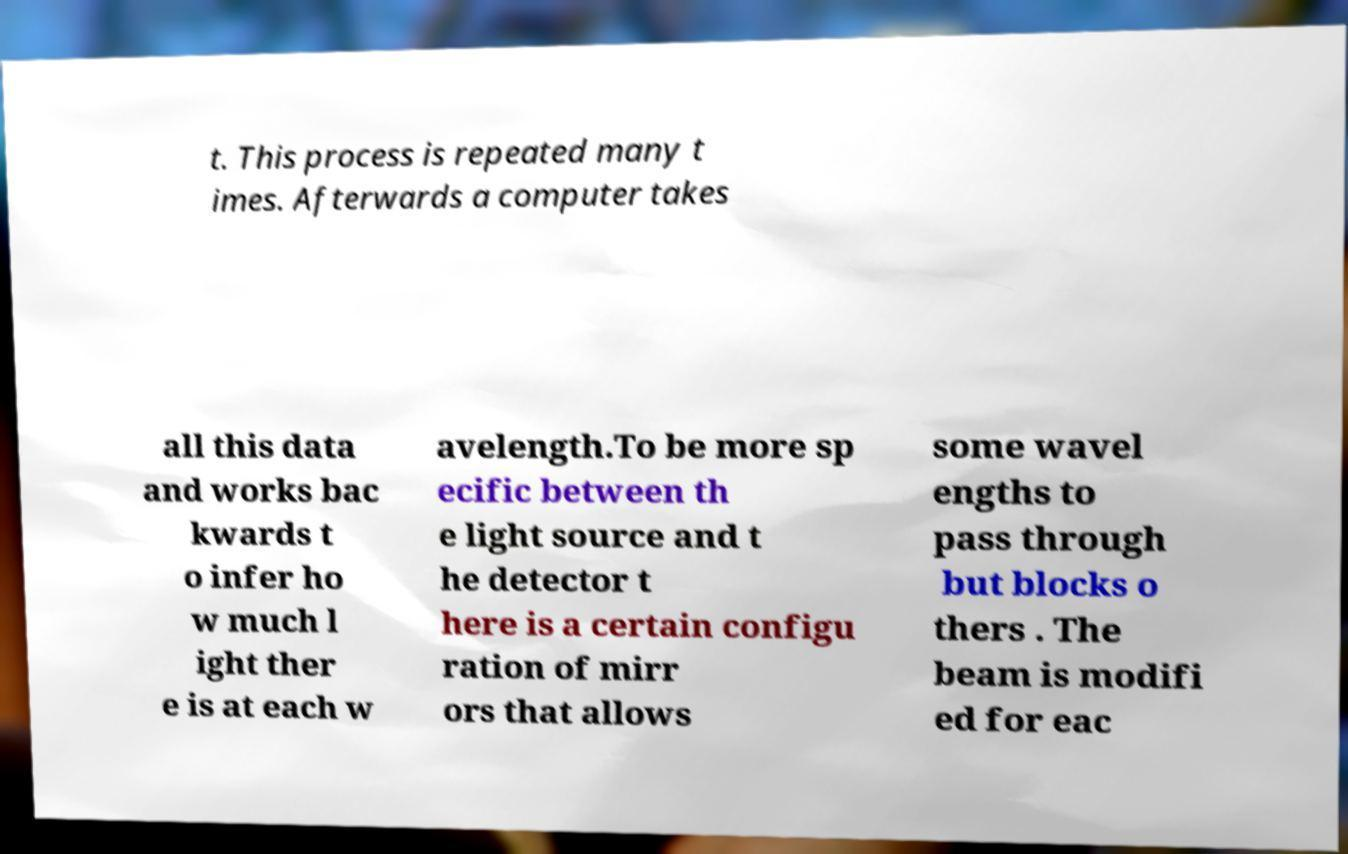What messages or text are displayed in this image? I need them in a readable, typed format. t. This process is repeated many t imes. Afterwards a computer takes all this data and works bac kwards t o infer ho w much l ight ther e is at each w avelength.To be more sp ecific between th e light source and t he detector t here is a certain configu ration of mirr ors that allows some wavel engths to pass through but blocks o thers . The beam is modifi ed for eac 